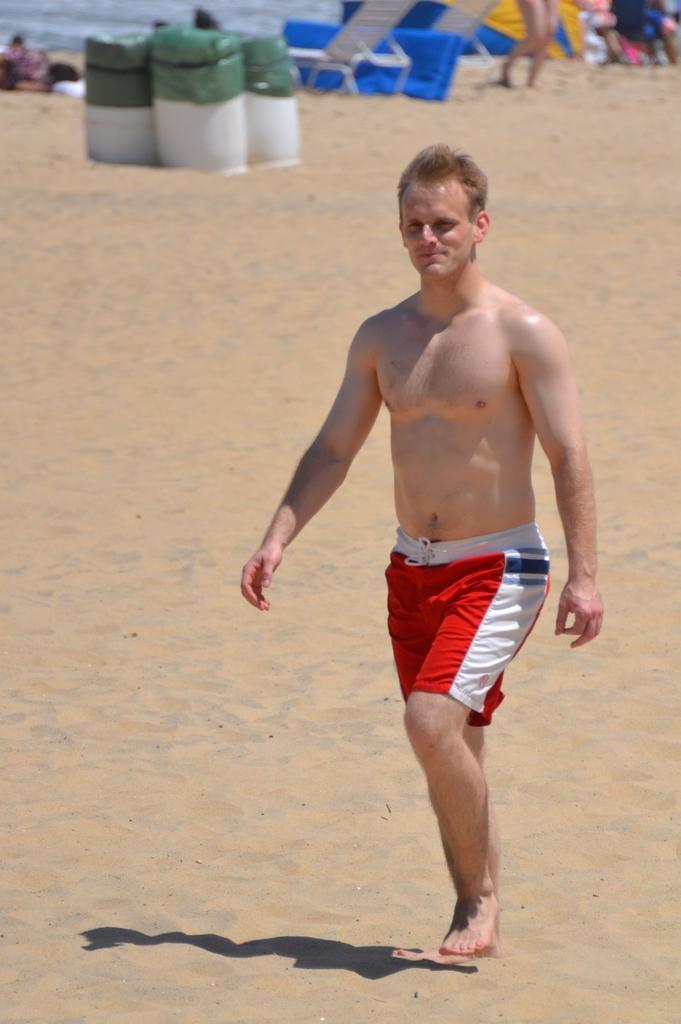Describe this image in one or two sentences. In this image in the front there is a person walking. In the background there are objects which are white and green in colour, there are tents and there are persons and there is water. 